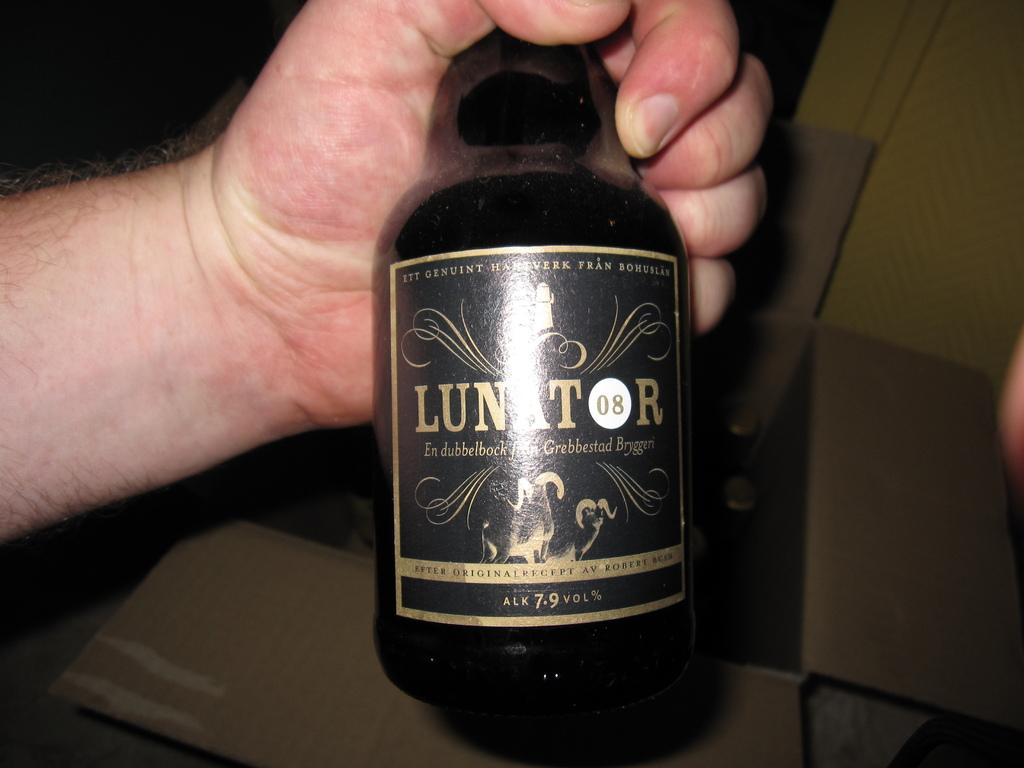<image>
Share a concise interpretation of the image provided. Someone holds a bottle of Lunator 7.9% in their hand. 